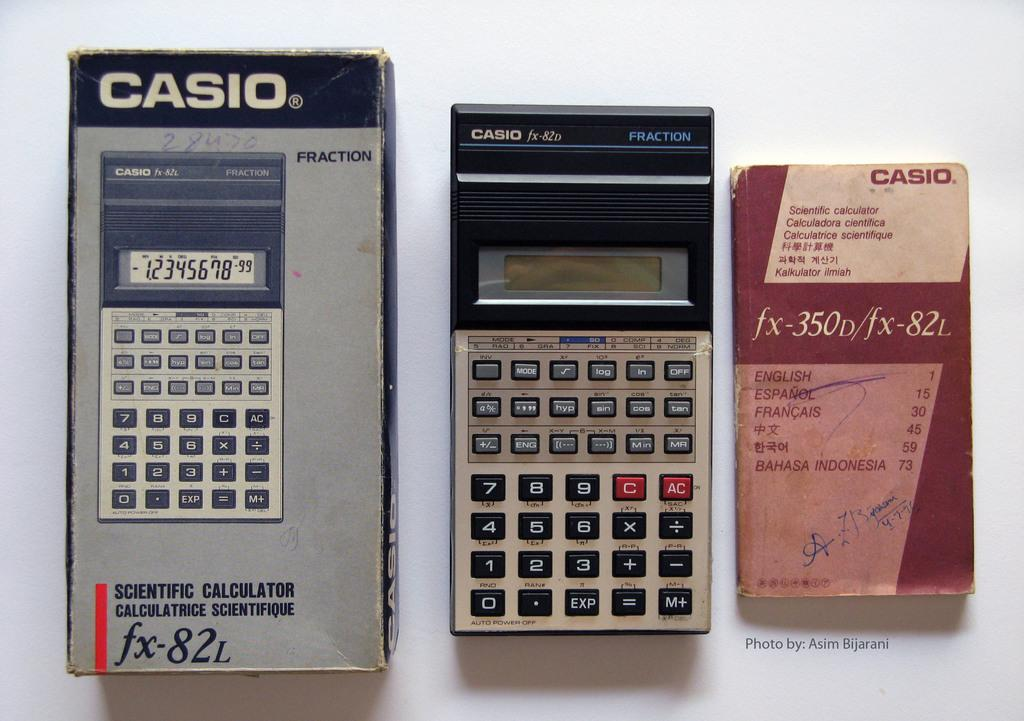<image>
Provide a brief description of the given image. old calculator from the brand casino along with box and book 